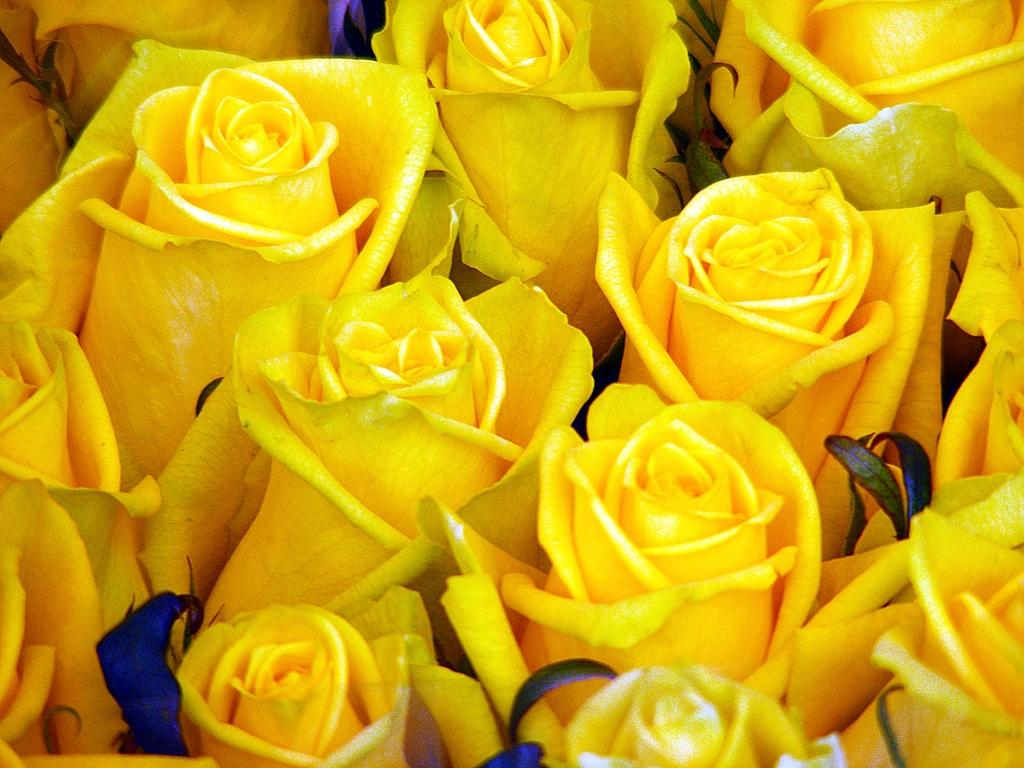What type of flowers are in the picture? There is a cluster of yellow roses in the picture. Can you describe the color of the flowers? The flowers are yellow. How are the flowers arranged in the picture? The flowers are clustered together. How many beads are scattered around the yellow roses in the picture? There are no beads present in the image; it only features a cluster of yellow roses. 